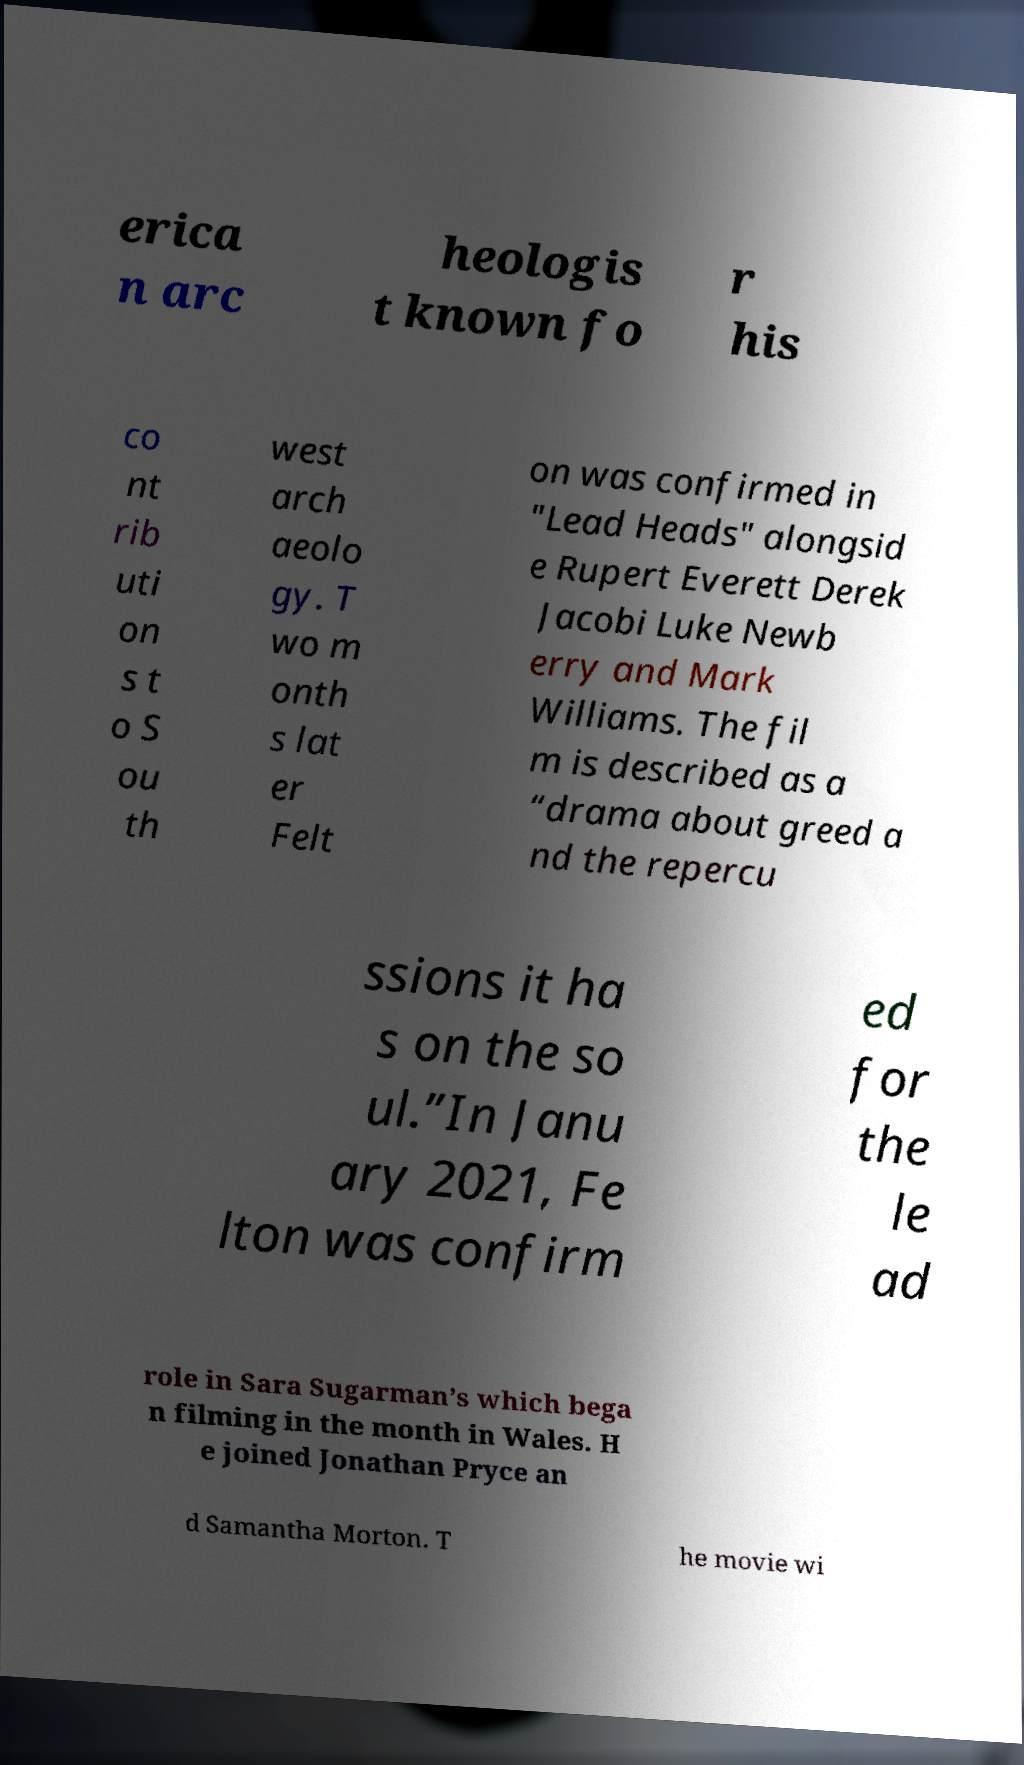Can you read and provide the text displayed in the image?This photo seems to have some interesting text. Can you extract and type it out for me? erica n arc heologis t known fo r his co nt rib uti on s t o S ou th west arch aeolo gy. T wo m onth s lat er Felt on was confirmed in "Lead Heads" alongsid e Rupert Everett Derek Jacobi Luke Newb erry and Mark Williams. The fil m is described as a “drama about greed a nd the repercu ssions it ha s on the so ul.”In Janu ary 2021, Fe lton was confirm ed for the le ad role in Sara Sugarman’s which bega n filming in the month in Wales. H e joined Jonathan Pryce an d Samantha Morton. T he movie wi 